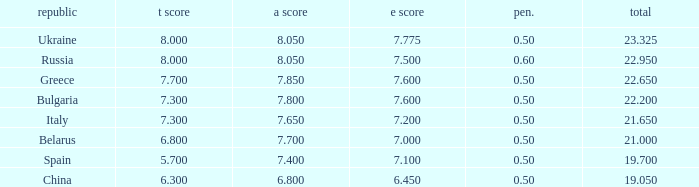What E score has the T score of 8 and a number smaller than 22.95? None. 